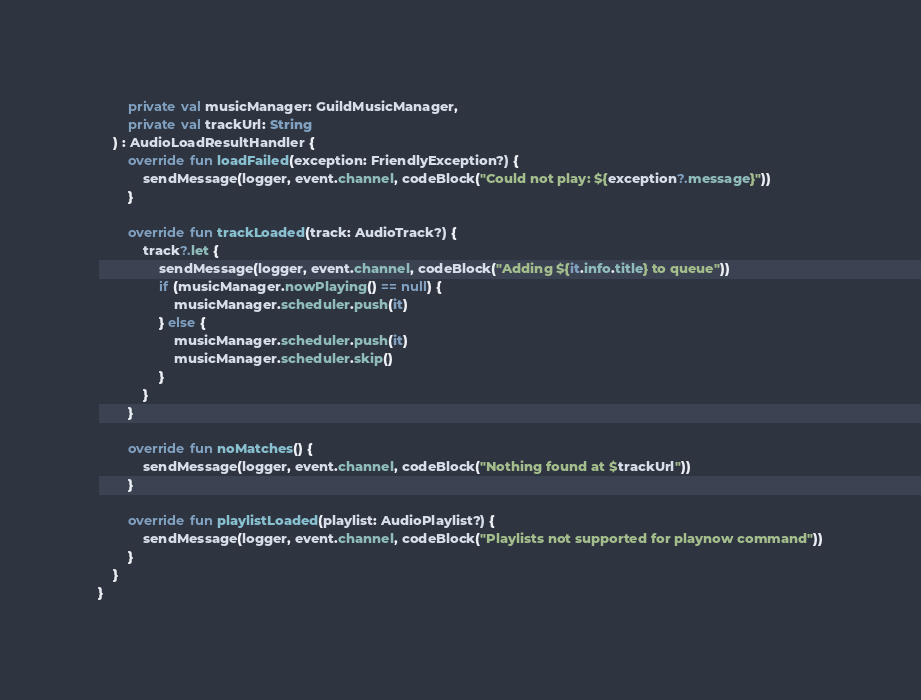<code> <loc_0><loc_0><loc_500><loc_500><_Kotlin_>        private val musicManager: GuildMusicManager,
        private val trackUrl: String
    ) : AudioLoadResultHandler {
        override fun loadFailed(exception: FriendlyException?) {
            sendMessage(logger, event.channel, codeBlock("Could not play: ${exception?.message}"))
        }

        override fun trackLoaded(track: AudioTrack?) {
            track?.let {
                sendMessage(logger, event.channel, codeBlock("Adding ${it.info.title} to queue"))
                if (musicManager.nowPlaying() == null) {
                    musicManager.scheduler.push(it)
                } else {
                    musicManager.scheduler.push(it)
                    musicManager.scheduler.skip()
                }
            }
        }

        override fun noMatches() {
            sendMessage(logger, event.channel, codeBlock("Nothing found at $trackUrl"))
        }

        override fun playlistLoaded(playlist: AudioPlaylist?) {
            sendMessage(logger, event.channel, codeBlock("Playlists not supported for playnow command"))
        }
    }
}
</code> 